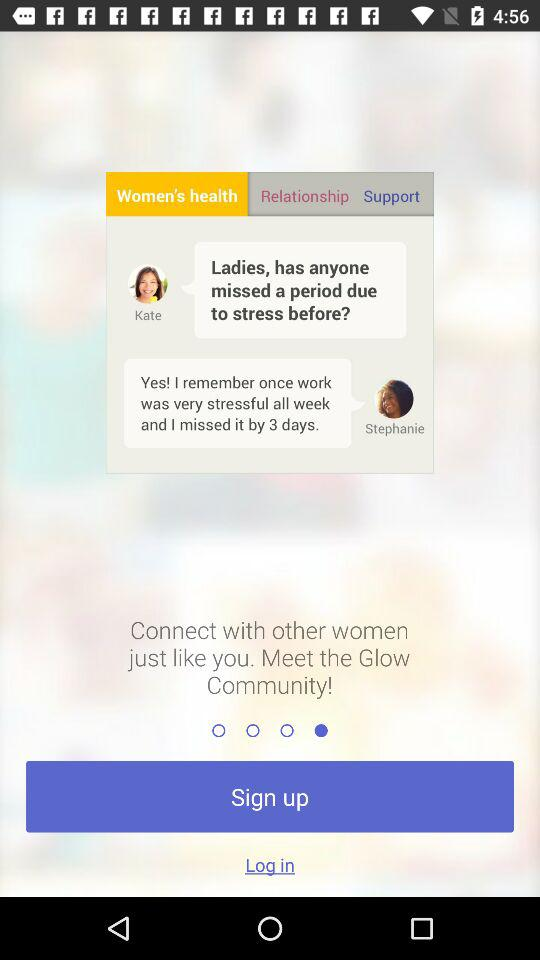What is the name of the application? The name of the application is "Glow". 